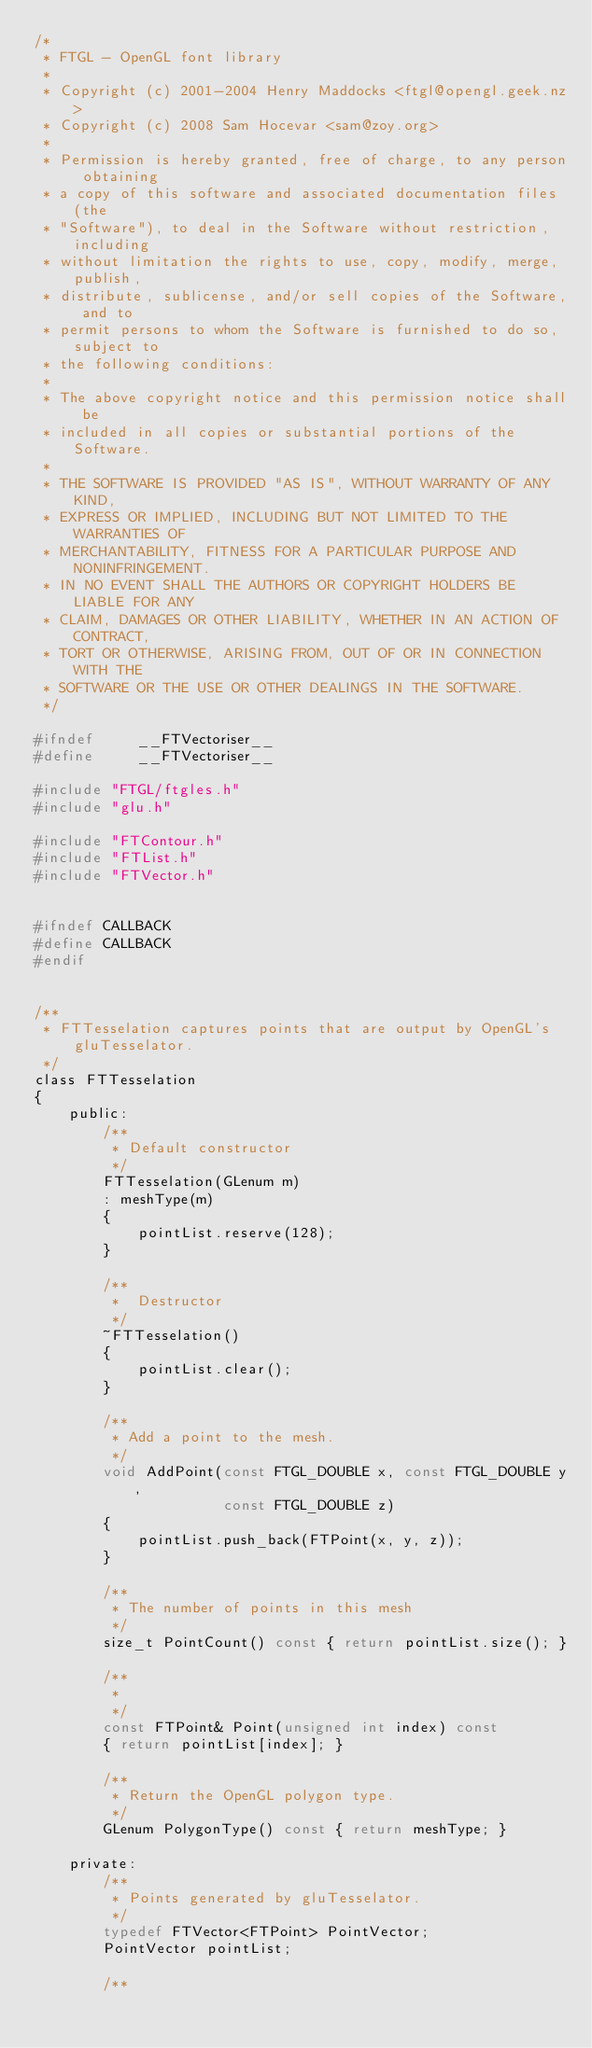<code> <loc_0><loc_0><loc_500><loc_500><_C_>/*
 * FTGL - OpenGL font library
 *
 * Copyright (c) 2001-2004 Henry Maddocks <ftgl@opengl.geek.nz>
 * Copyright (c) 2008 Sam Hocevar <sam@zoy.org>
 *
 * Permission is hereby granted, free of charge, to any person obtaining
 * a copy of this software and associated documentation files (the
 * "Software"), to deal in the Software without restriction, including
 * without limitation the rights to use, copy, modify, merge, publish,
 * distribute, sublicense, and/or sell copies of the Software, and to
 * permit persons to whom the Software is furnished to do so, subject to
 * the following conditions:
 *
 * The above copyright notice and this permission notice shall be
 * included in all copies or substantial portions of the Software.
 *
 * THE SOFTWARE IS PROVIDED "AS IS", WITHOUT WARRANTY OF ANY KIND,
 * EXPRESS OR IMPLIED, INCLUDING BUT NOT LIMITED TO THE WARRANTIES OF
 * MERCHANTABILITY, FITNESS FOR A PARTICULAR PURPOSE AND NONINFRINGEMENT.
 * IN NO EVENT SHALL THE AUTHORS OR COPYRIGHT HOLDERS BE LIABLE FOR ANY
 * CLAIM, DAMAGES OR OTHER LIABILITY, WHETHER IN AN ACTION OF CONTRACT,
 * TORT OR OTHERWISE, ARISING FROM, OUT OF OR IN CONNECTION WITH THE
 * SOFTWARE OR THE USE OR OTHER DEALINGS IN THE SOFTWARE.
 */

#ifndef     __FTVectoriser__
#define     __FTVectoriser__

#include "FTGL/ftgles.h"
#include "glu.h"

#include "FTContour.h"
#include "FTList.h"
#include "FTVector.h"


#ifndef CALLBACK
#define CALLBACK
#endif


/**
 * FTTesselation captures points that are output by OpenGL's gluTesselator.
 */
class FTTesselation
{
    public:
        /**
         * Default constructor
         */
        FTTesselation(GLenum m)
        : meshType(m)
        {
            pointList.reserve(128);
        }

        /**
         *  Destructor
         */
        ~FTTesselation()
        {
            pointList.clear();
        }

        /**
         * Add a point to the mesh.
         */
        void AddPoint(const FTGL_DOUBLE x, const FTGL_DOUBLE y,
                      const FTGL_DOUBLE z)
        {
            pointList.push_back(FTPoint(x, y, z));
        }

        /**
         * The number of points in this mesh
         */
        size_t PointCount() const { return pointList.size(); }

        /**
         *
         */
        const FTPoint& Point(unsigned int index) const
        { return pointList[index]; }

        /**
         * Return the OpenGL polygon type.
         */
        GLenum PolygonType() const { return meshType; }

    private:
        /**
         * Points generated by gluTesselator.
         */
        typedef FTVector<FTPoint> PointVector;
        PointVector pointList;

        /**</code> 